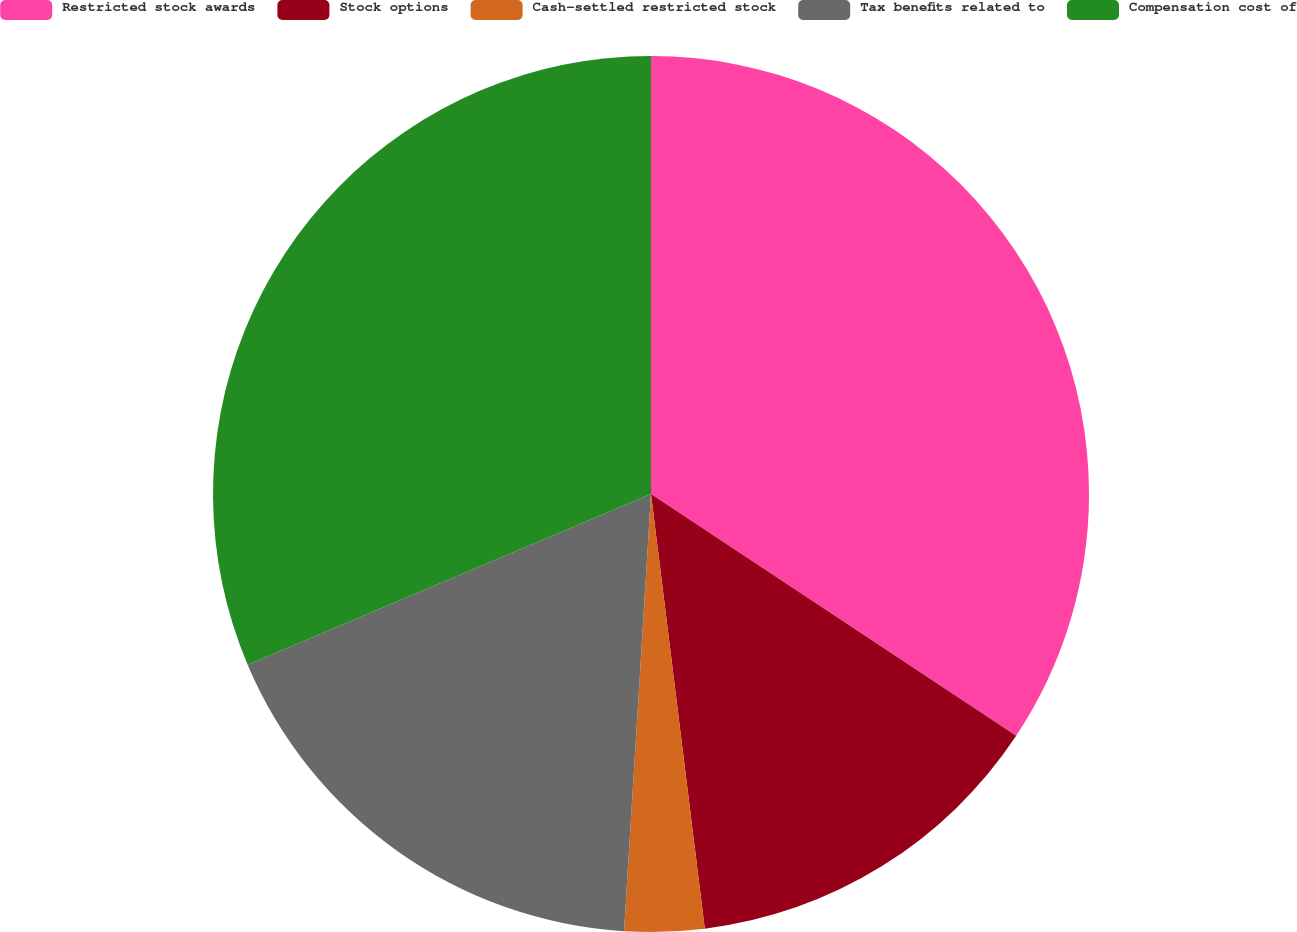Convert chart. <chart><loc_0><loc_0><loc_500><loc_500><pie_chart><fcel>Restricted stock awards<fcel>Stock options<fcel>Cash-settled restricted stock<fcel>Tax benefits related to<fcel>Compensation cost of<nl><fcel>34.31%<fcel>13.73%<fcel>2.94%<fcel>17.65%<fcel>31.37%<nl></chart> 